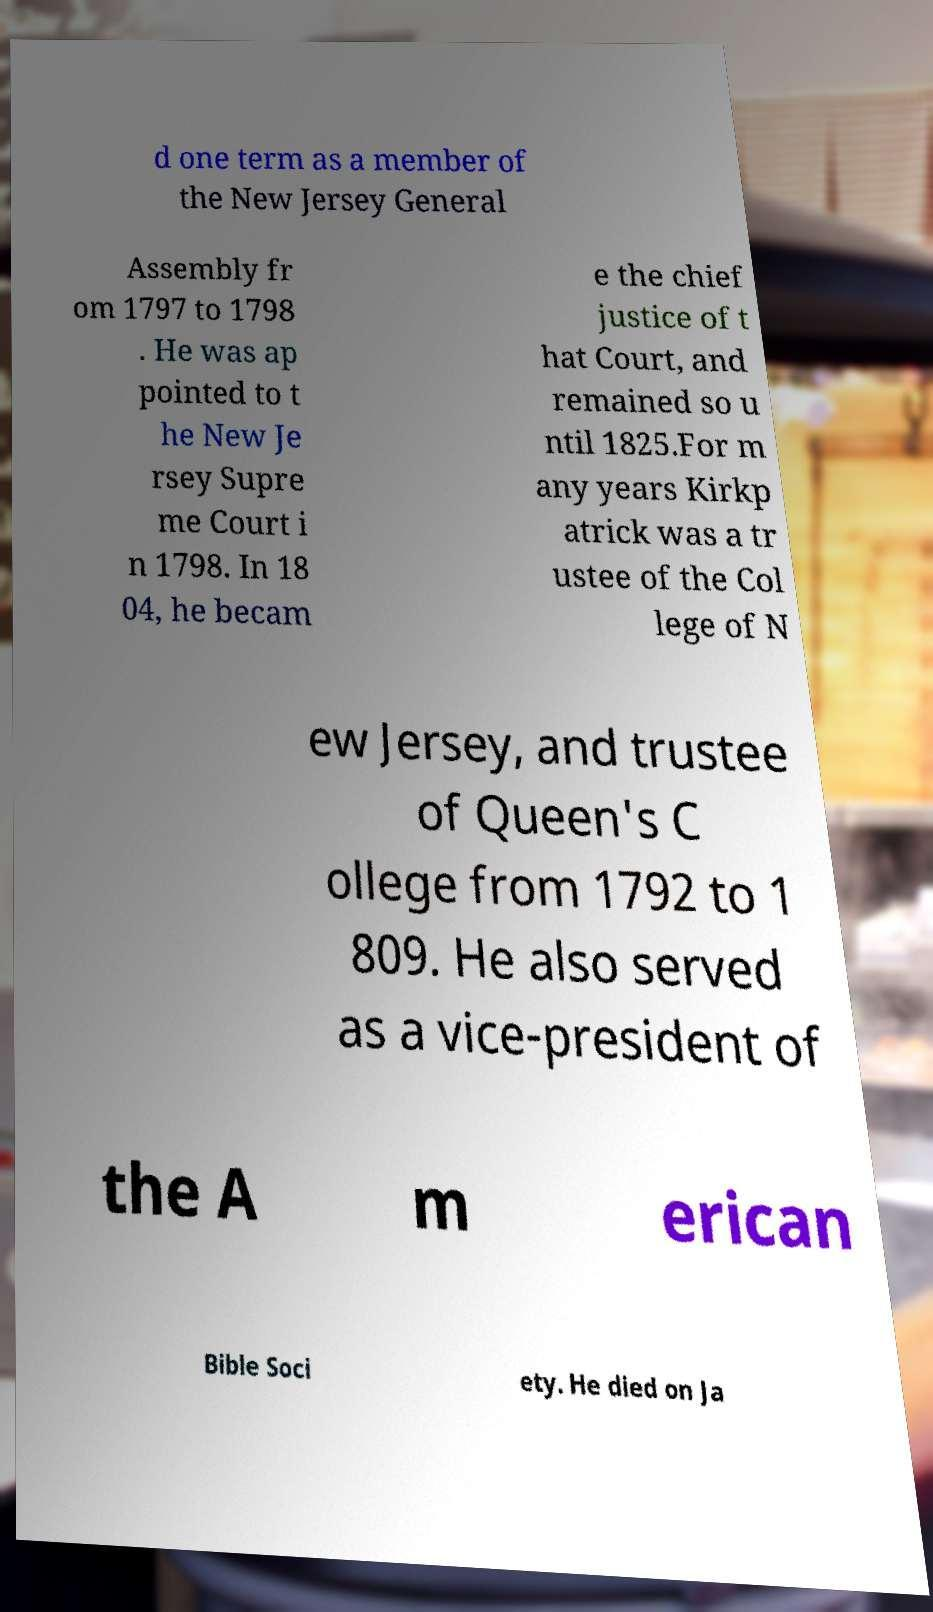Could you extract and type out the text from this image? d one term as a member of the New Jersey General Assembly fr om 1797 to 1798 . He was ap pointed to t he New Je rsey Supre me Court i n 1798. In 18 04, he becam e the chief justice of t hat Court, and remained so u ntil 1825.For m any years Kirkp atrick was a tr ustee of the Col lege of N ew Jersey, and trustee of Queen's C ollege from 1792 to 1 809. He also served as a vice-president of the A m erican Bible Soci ety. He died on Ja 